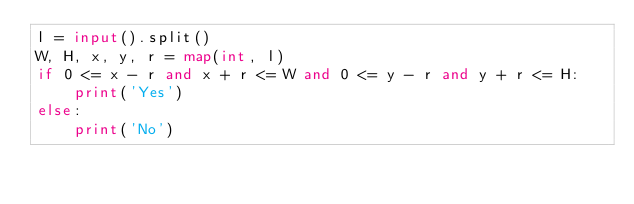<code> <loc_0><loc_0><loc_500><loc_500><_Python_>l = input().split()
W, H, x, y, r = map(int, l)
if 0 <= x - r and x + r <= W and 0 <= y - r and y + r <= H:
    print('Yes')
else:
    print('No')
</code> 